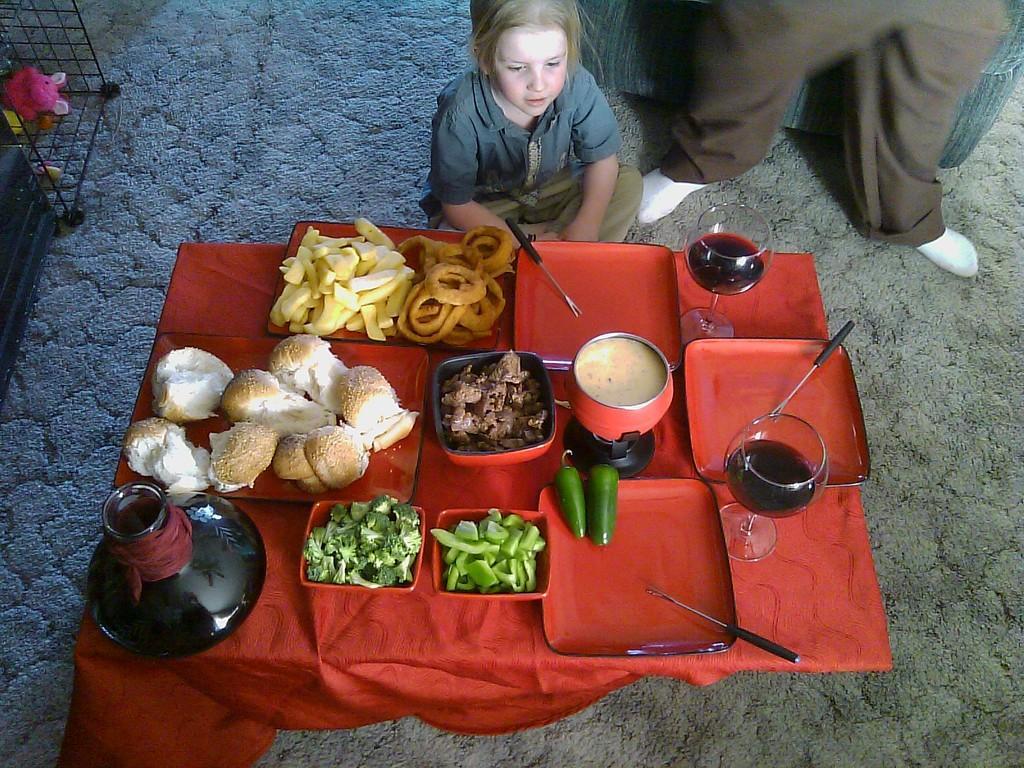Can you describe this image briefly? In this picture I can see there is a girl sitting and there is a table in front of her and there are different bowls with broccoli, capsicum and there are chilli and wine glasses. 